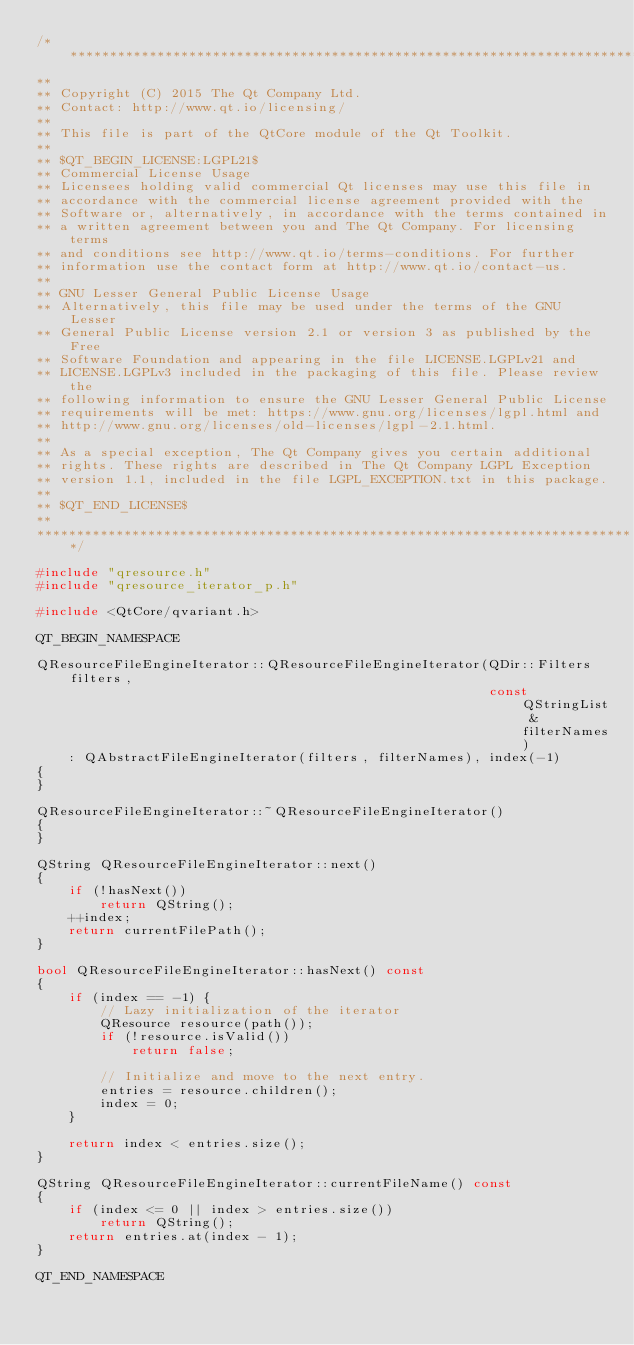Convert code to text. <code><loc_0><loc_0><loc_500><loc_500><_C++_>/****************************************************************************
**
** Copyright (C) 2015 The Qt Company Ltd.
** Contact: http://www.qt.io/licensing/
**
** This file is part of the QtCore module of the Qt Toolkit.
**
** $QT_BEGIN_LICENSE:LGPL21$
** Commercial License Usage
** Licensees holding valid commercial Qt licenses may use this file in
** accordance with the commercial license agreement provided with the
** Software or, alternatively, in accordance with the terms contained in
** a written agreement between you and The Qt Company. For licensing terms
** and conditions see http://www.qt.io/terms-conditions. For further
** information use the contact form at http://www.qt.io/contact-us.
**
** GNU Lesser General Public License Usage
** Alternatively, this file may be used under the terms of the GNU Lesser
** General Public License version 2.1 or version 3 as published by the Free
** Software Foundation and appearing in the file LICENSE.LGPLv21 and
** LICENSE.LGPLv3 included in the packaging of this file. Please review the
** following information to ensure the GNU Lesser General Public License
** requirements will be met: https://www.gnu.org/licenses/lgpl.html and
** http://www.gnu.org/licenses/old-licenses/lgpl-2.1.html.
**
** As a special exception, The Qt Company gives you certain additional
** rights. These rights are described in The Qt Company LGPL Exception
** version 1.1, included in the file LGPL_EXCEPTION.txt in this package.
**
** $QT_END_LICENSE$
**
****************************************************************************/

#include "qresource.h"
#include "qresource_iterator_p.h"

#include <QtCore/qvariant.h>

QT_BEGIN_NAMESPACE

QResourceFileEngineIterator::QResourceFileEngineIterator(QDir::Filters filters,
                                                         const QStringList &filterNames)
    : QAbstractFileEngineIterator(filters, filterNames), index(-1)
{
}

QResourceFileEngineIterator::~QResourceFileEngineIterator()
{
}

QString QResourceFileEngineIterator::next()
{
    if (!hasNext())
        return QString();
    ++index;
    return currentFilePath();
}

bool QResourceFileEngineIterator::hasNext() const
{
    if (index == -1) {
        // Lazy initialization of the iterator
        QResource resource(path());
        if (!resource.isValid())
            return false;

        // Initialize and move to the next entry.
        entries = resource.children();
        index = 0;
    }

    return index < entries.size();
}

QString QResourceFileEngineIterator::currentFileName() const
{
    if (index <= 0 || index > entries.size())
        return QString();
    return entries.at(index - 1);
}

QT_END_NAMESPACE
</code> 